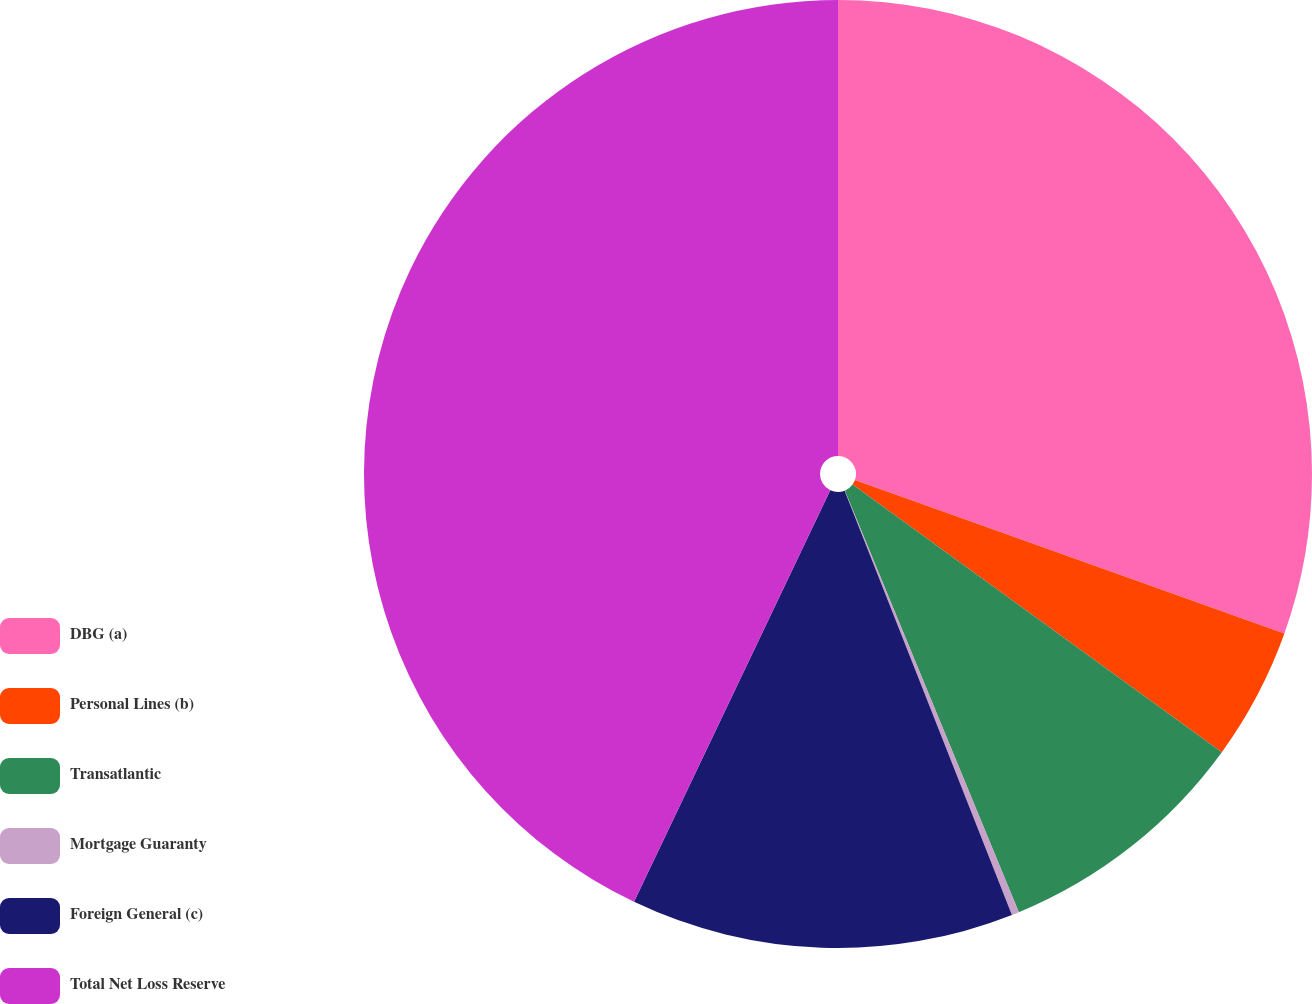<chart> <loc_0><loc_0><loc_500><loc_500><pie_chart><fcel>DBG (a)<fcel>Personal Lines (b)<fcel>Transatlantic<fcel>Mortgage Guaranty<fcel>Foreign General (c)<fcel>Total Net Loss Reserve<nl><fcel>30.46%<fcel>4.52%<fcel>8.79%<fcel>0.25%<fcel>13.06%<fcel>42.92%<nl></chart> 